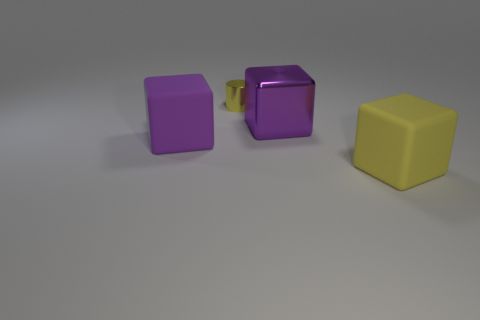Is there a block that has the same color as the small metallic cylinder?
Offer a terse response. Yes. There is a matte block that is on the left side of the yellow metal thing; what is its size?
Offer a terse response. Large. The object that is the same material as the tiny yellow cylinder is what shape?
Give a very brief answer. Cube. Are there any other things of the same color as the metallic block?
Your answer should be very brief. Yes. There is a tiny shiny object behind the big object that is to the left of the cylinder; what is its color?
Your answer should be compact. Yellow. How many small objects are metallic blocks or shiny cylinders?
Provide a succinct answer. 1. What material is the other big purple thing that is the same shape as the purple metal thing?
Keep it short and to the point. Rubber. Is there any other thing that has the same material as the tiny yellow thing?
Provide a short and direct response. Yes. The small metallic object is what color?
Offer a very short reply. Yellow. Is the metallic cylinder the same color as the metallic block?
Provide a succinct answer. No. 